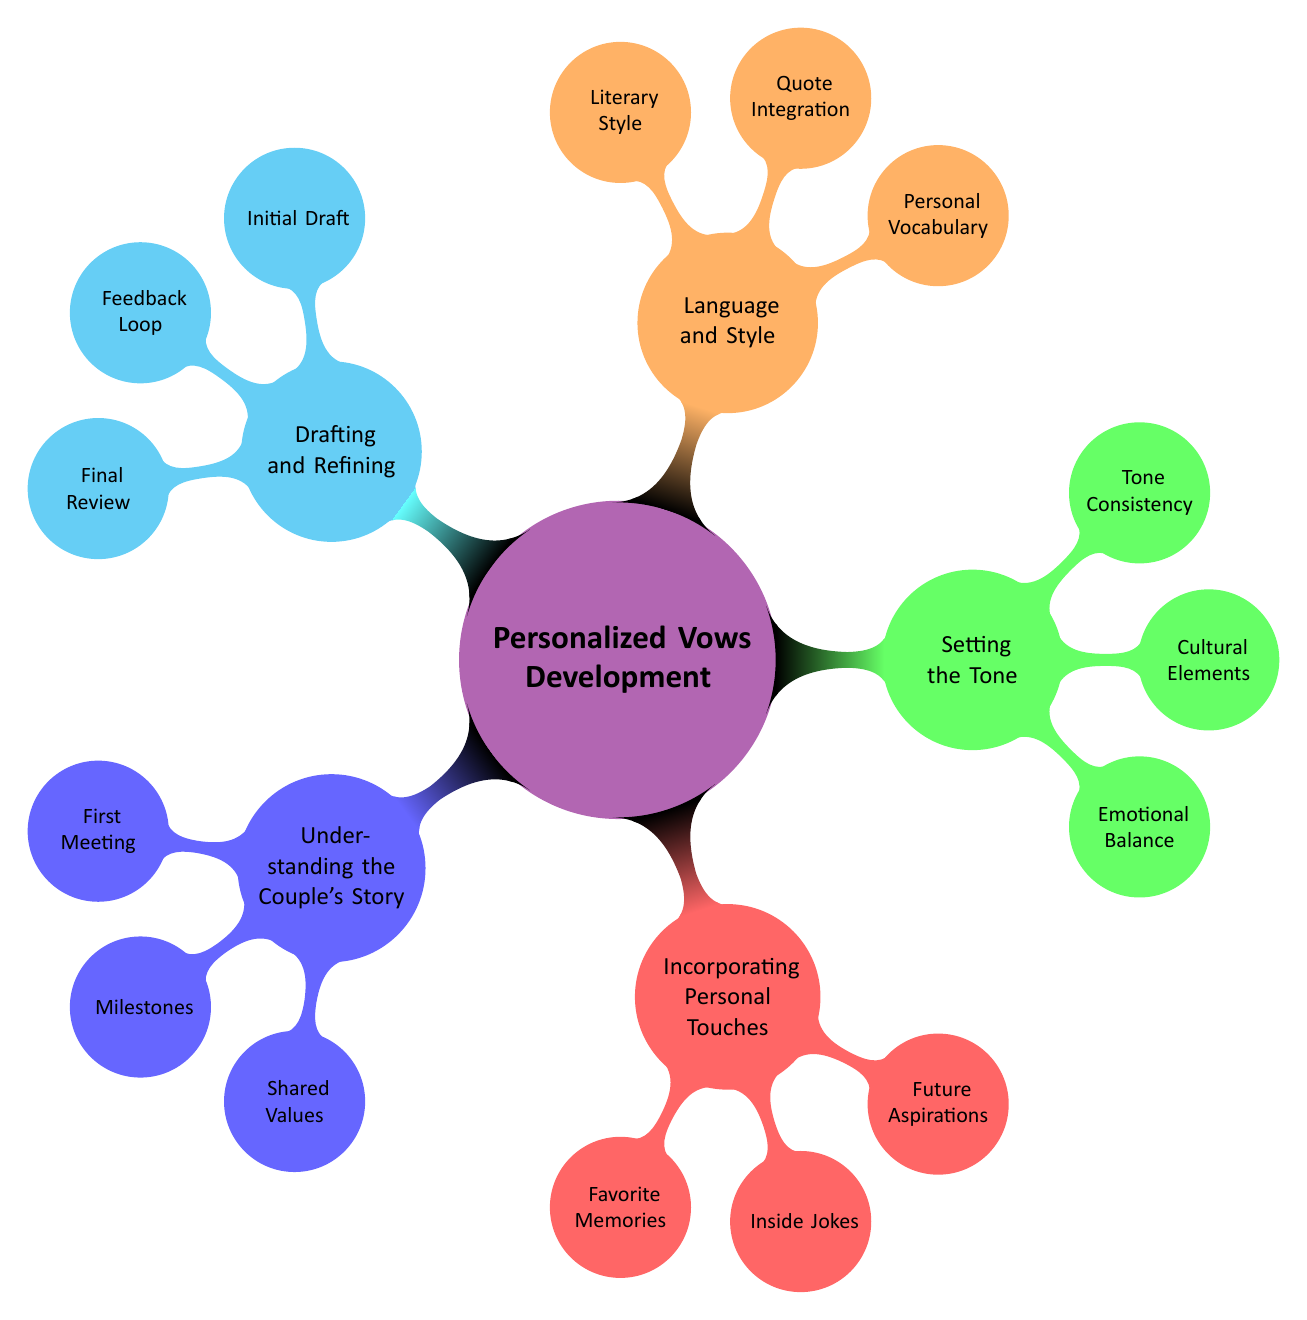What is the primary topic of the mind map? The central node of the diagram clearly labels the primary topic as "Personalized Vows Development."
Answer: Personalized Vows Development How many main branches are there in the diagram? The diagram shows five main branches stemming from the central node, which include Understanding the Couple's Story, Incorporating Personal Touches, Setting the Tone, Language and Style, and Drafting and Refining.
Answer: Five What aspect focuses on the couple's emotional balance? Under the branch "Setting the Tone," it specifically mentions "Emotional Balance" as an element to consider.
Answer: Emotional Balance Which branch includes "Inside Jokes"? The branch titled "Incorporating Personal Touches" lists "Inside Jokes" as one of the elements to personalize vows.
Answer: Incorporating Personal Touches What is the last step listed under Drafting and Refining? The final step mentioned under the "Drafting and Refining" branch is "Final Review," indicating the last stage before finalizing vows.
Answer: Final Review What type of humor does the diagram suggest incorporating into vows? The diagram suggests incorporating humor through "Inside Jokes" as highlighted in the "Incorporating Personal Touches" branch.
Answer: Inside Jokes How does "Quote Integration" relate to the overall language style? "Quote Integration" is listed under the "Language and Style" branch, indicating its relevance in selecting quotes that enhance the vows’ style and personal touch.
Answer: Language and Style What does the branch "Understanding the Couple's Story" focus on? This branch emphasizes exploring the couple's narrative through elements like "First Meeting," "Milestones," and "Shared Values," highlighting the importance of their shared history.
Answer: Understanding the Couple's Story Which two elements enhance the emotional tone of the vows? The elements "Emotional Balance" and "Tone Consistency" under "Setting the Tone" contribute to maintaining an appropriate emotional vibe throughout the vows.
Answer: Emotional Balance and Tone Consistency 